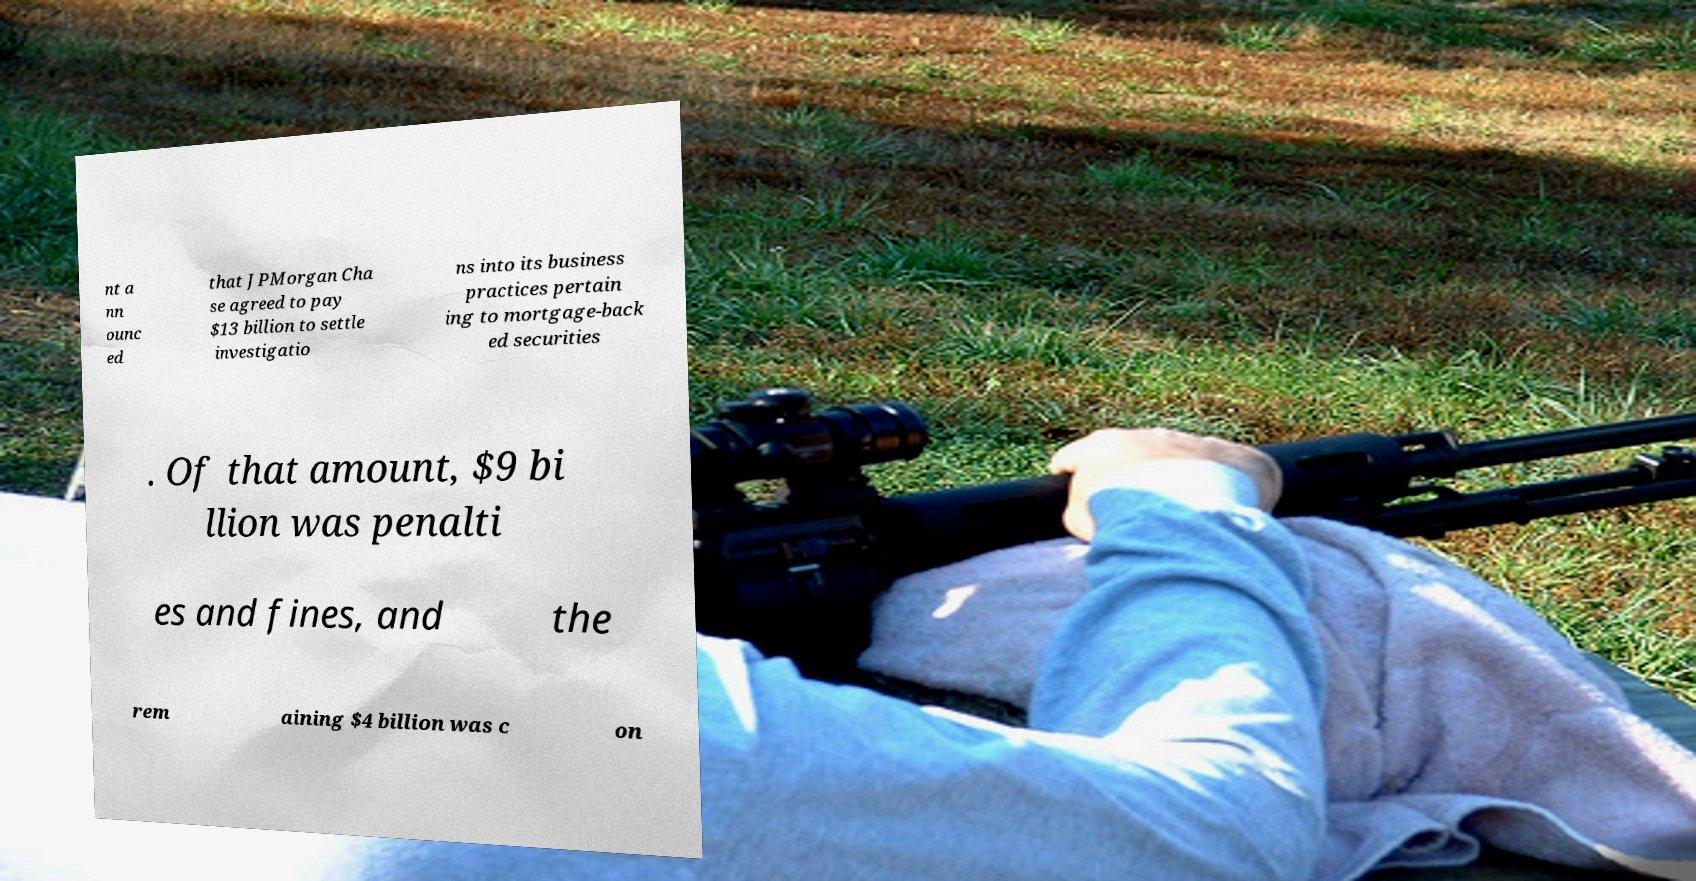For documentation purposes, I need the text within this image transcribed. Could you provide that? nt a nn ounc ed that JPMorgan Cha se agreed to pay $13 billion to settle investigatio ns into its business practices pertain ing to mortgage-back ed securities . Of that amount, $9 bi llion was penalti es and fines, and the rem aining $4 billion was c on 